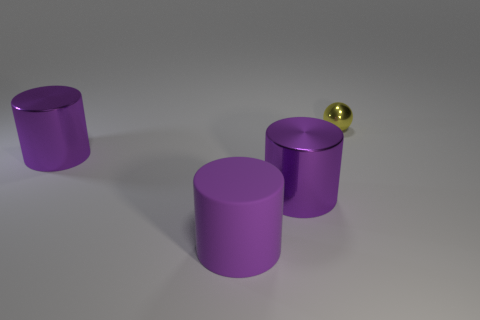How many other objects are there of the same material as the tiny ball?
Offer a terse response. 2. Is the number of large rubber cylinders that are behind the small yellow metal ball greater than the number of yellow metal things in front of the large rubber cylinder?
Your response must be concise. No. What is the object that is to the left of the big purple matte thing made of?
Ensure brevity in your answer.  Metal. Is the shape of the tiny yellow object the same as the big purple matte object?
Make the answer very short. No. Are there any other things that have the same color as the rubber thing?
Give a very brief answer. Yes. Are there more small metallic spheres behind the yellow ball than large purple cylinders?
Provide a succinct answer. No. What is the color of the large cylinder that is to the left of the matte cylinder?
Offer a very short reply. Purple. Do the matte object and the yellow metallic object have the same size?
Ensure brevity in your answer.  No. What is the size of the purple rubber cylinder?
Offer a terse response. Large. Are there more big cylinders than big metallic things?
Provide a succinct answer. Yes. 